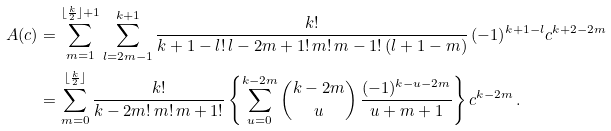<formula> <loc_0><loc_0><loc_500><loc_500>A ( c ) & = \sum _ { m = 1 } ^ { \lfloor \frac { k } { 2 } \rfloor + 1 } \sum _ { l = 2 m - 1 } ^ { k + 1 } \frac { k ! } { k + 1 - l ! \, l - 2 m + 1 ! \, m ! \, m - 1 ! \, ( l + 1 - m ) } \, ( - 1 ) ^ { k + 1 - l } c ^ { k + 2 - 2 m } \\ & = \sum _ { m = 0 } ^ { \lfloor \frac { k } { 2 } \rfloor } \frac { k ! } { k - 2 m ! \, m ! \, m + 1 ! } \left \{ \sum _ { u = 0 } ^ { k - 2 m } \binom { k - 2 m } { u } \, \frac { ( - 1 ) ^ { k - u - 2 m } } { u + m + 1 } \right \} c ^ { k - 2 m } \, .</formula> 